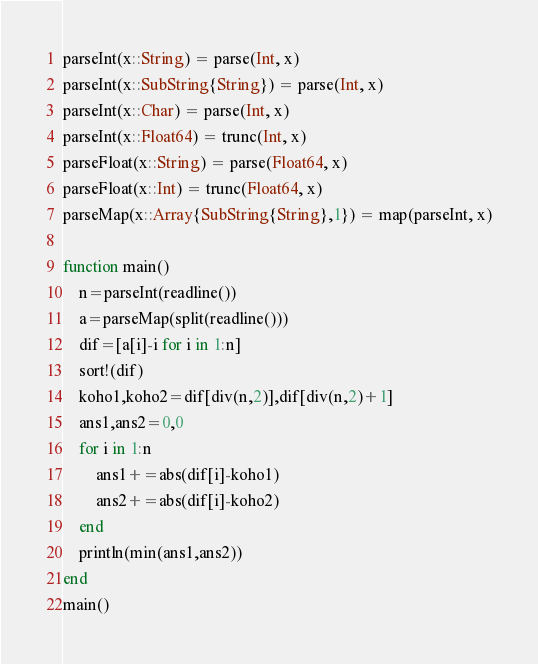<code> <loc_0><loc_0><loc_500><loc_500><_Julia_>parseInt(x::String) = parse(Int, x)
parseInt(x::SubString{String}) = parse(Int, x)
parseInt(x::Char) = parse(Int, x)
parseInt(x::Float64) = trunc(Int, x)
parseFloat(x::String) = parse(Float64, x)
parseFloat(x::Int) = trunc(Float64, x)
parseMap(x::Array{SubString{String},1}) = map(parseInt, x)

function main()
    n=parseInt(readline())
    a=parseMap(split(readline()))
    dif=[a[i]-i for i in 1:n]
    sort!(dif)
    koho1,koho2=dif[div(n,2)],dif[div(n,2)+1]
    ans1,ans2=0,0
    for i in 1:n
        ans1+=abs(dif[i]-koho1)
        ans2+=abs(dif[i]-koho2)
    end
    println(min(ans1,ans2))
end
main()</code> 